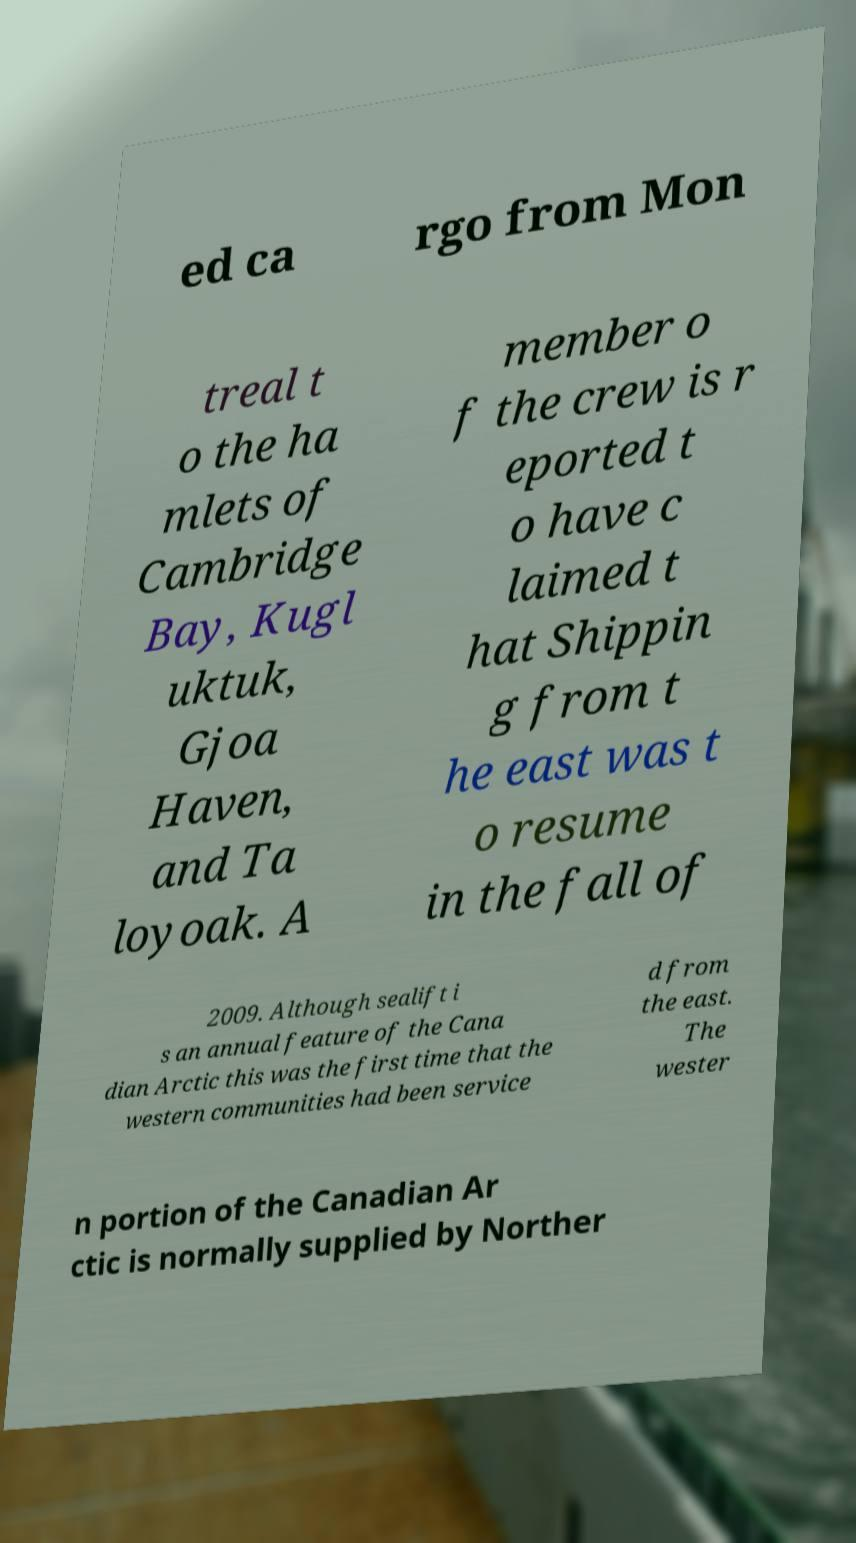Could you assist in decoding the text presented in this image and type it out clearly? ed ca rgo from Mon treal t o the ha mlets of Cambridge Bay, Kugl uktuk, Gjoa Haven, and Ta loyoak. A member o f the crew is r eported t o have c laimed t hat Shippin g from t he east was t o resume in the fall of 2009. Although sealift i s an annual feature of the Cana dian Arctic this was the first time that the western communities had been service d from the east. The wester n portion of the Canadian Ar ctic is normally supplied by Norther 